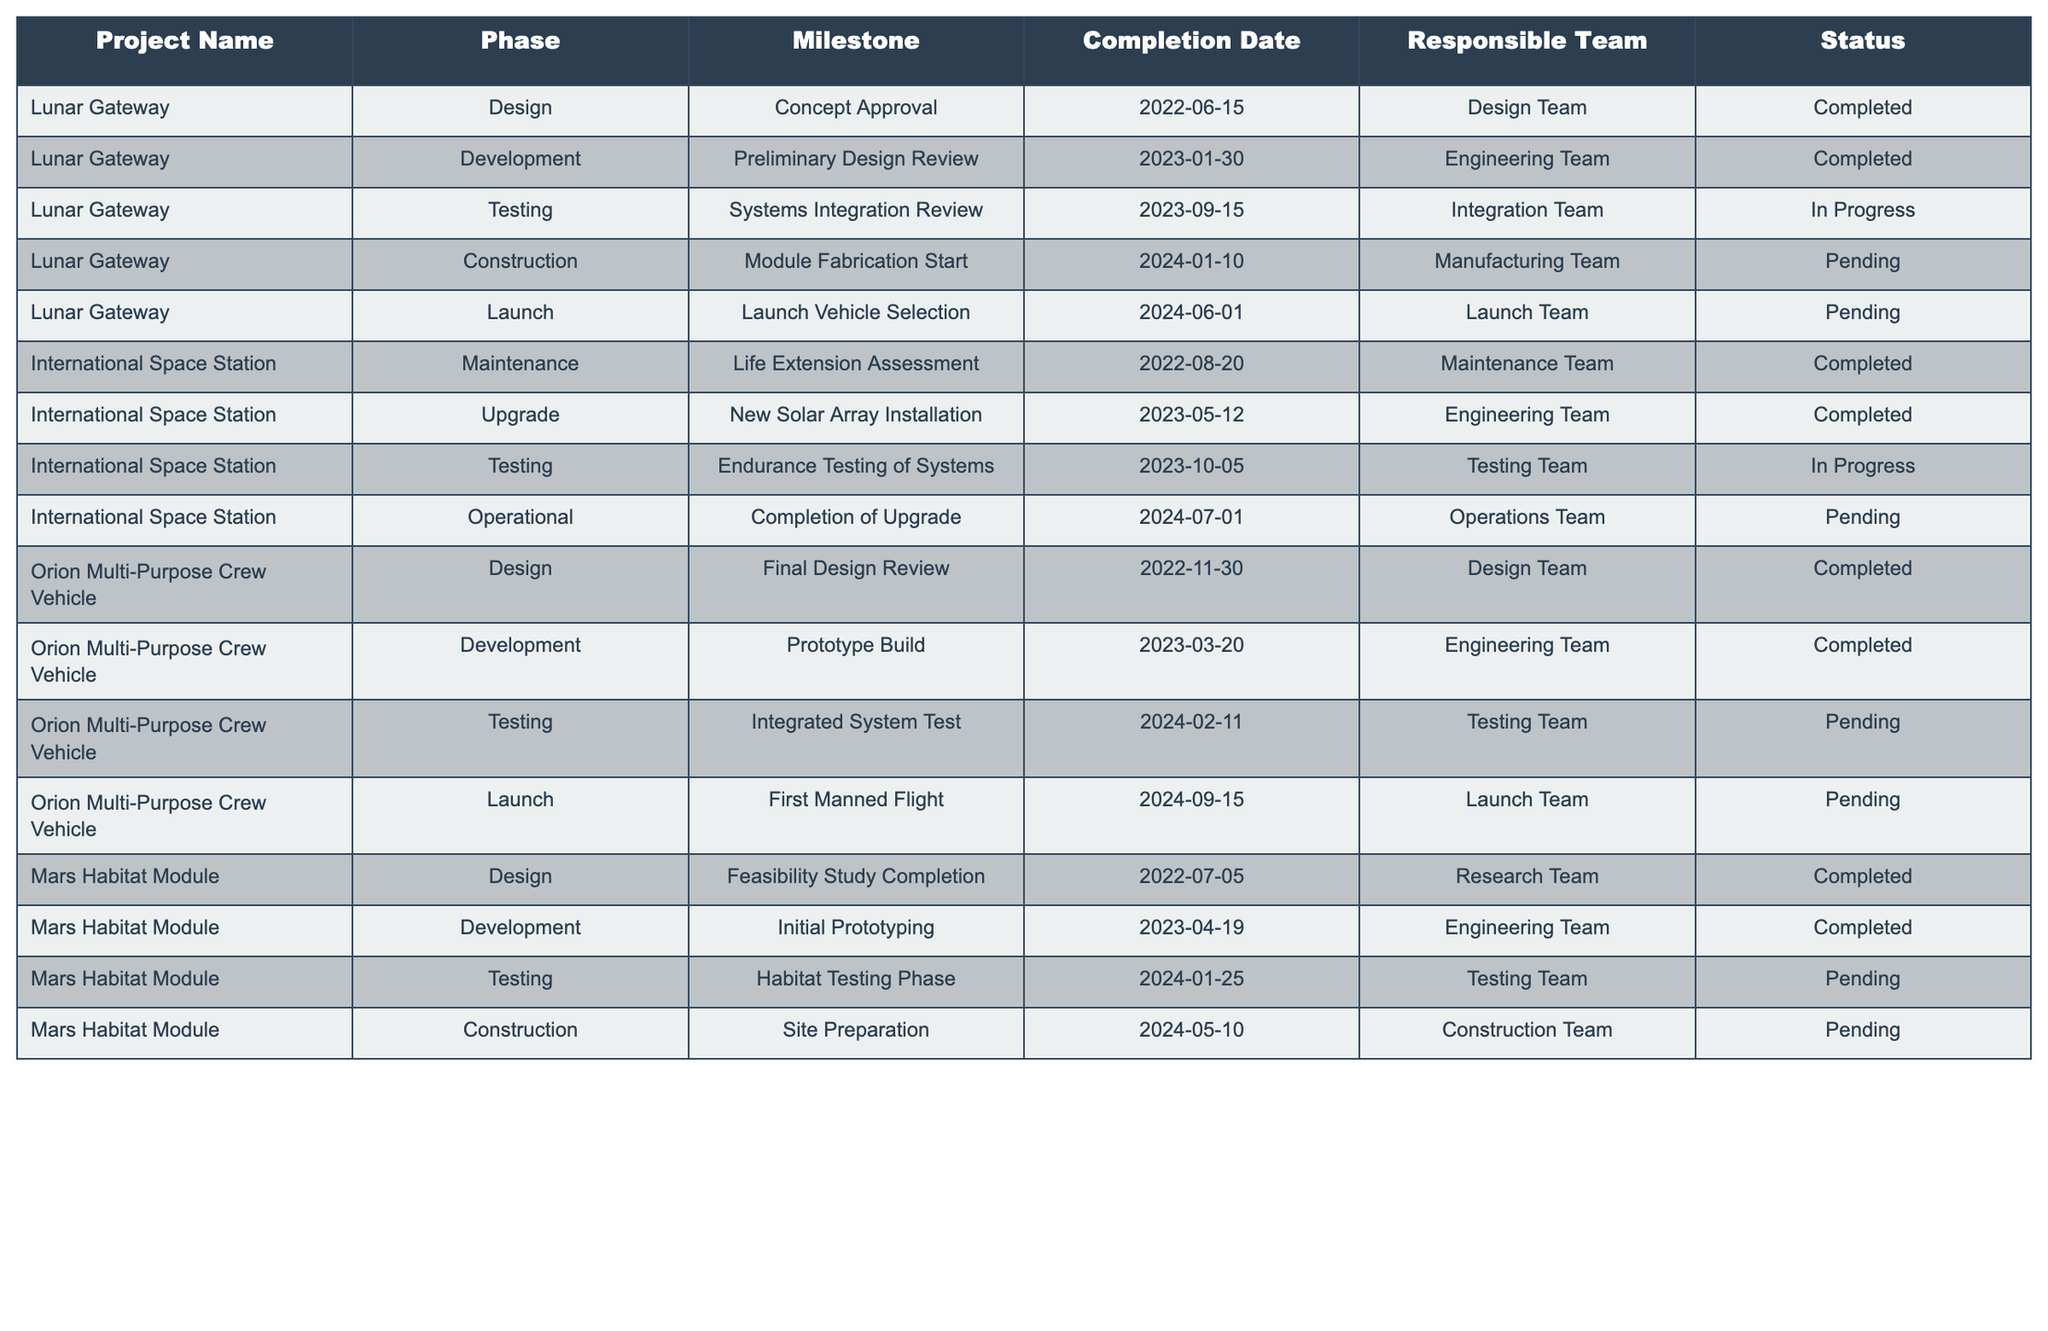What is the status of the Systems Integration Review for the Lunar Gateway project? Looking at the table, the Systems Integration Review for the Lunar Gateway is listed under the Testing phase with a status of "In Progress."
Answer: In Progress Which project has a completed Design phase milestone? By reviewing the table, it can be seen that both the Lunar Gateway and the Orion Multi-Purpose Crew Vehicle have a completed milestone in the Design phase, particularly "Concept Approval" and "Final Design Review," respectively.
Answer: Lunar Gateway and Orion Multi-Purpose Crew Vehicle How many milestones are pending for the Mars Habitat Module? The table shows that there are three milestones under the Mars Habitat Module: Habitat Testing Phase, Site Preparation, and one Development phase milestone. All three of these milestones are labeled as "Pending."
Answer: Three Is the Completion of Upgrade for the International Space Station scheduled before the Launch Vehicle Selection for the Lunar Gateway? The Completion of Upgrade is scheduled for 2024-07-01, while the Launch Vehicle Selection is set for 2024-06-01. Since 2024-06-01 comes before 2024-07-01, the statement is false.
Answer: No For the Orion Multi-Purpose Crew Vehicle, when is the first manned flight scheduled? The table indicates that the first manned flight for the Orion Multi-Purpose Crew Vehicle is scheduled for 2024-09-15 under the Launch phase.
Answer: 2024-09-15 Which team is responsible for the Integrated System Test of the Orion Multi-Purpose Crew Vehicle? According to the table, the responsible team for the Integrated System Test under the Testing phase for the Orion Multi-Purpose Crew Vehicle is the Testing Team.
Answer: Testing Team How many projects have completed their Development phase milestones? The table shows that both the Lunar Gateway and the Orion Multi-Purpose Crew Vehicle have completed milestones in the Development phase: Preliminary Design Review and Prototype Build, respectively. Thus, two projects have completed this phase.
Answer: Two What is the difference in completion dates between the Feasibility Study Completion of the Mars Habitat Module and the New Solar Array Installation of the International Space Station? The Feasibility Study Completion is on 2022-07-05, and the New Solar Array Installation is on 2023-05-12. The difference is approximately 10 months and 7 days.
Answer: 10 months and 7 days Are there any In Progress milestones for the Mars Habitat Module? The table indicates that all milestones for the Mars Habitat Module are pending; thus, there are no In Progress milestones for this project.
Answer: No Which project has the latest scheduled milestone overall, based on the table? Looking at the completion dates in the table, the latest scheduled milestone is the First Manned Flight for the Orion Multi-Purpose Crew Vehicle on 2024-09-15.
Answer: Orion Multi-Purpose Crew Vehicle 